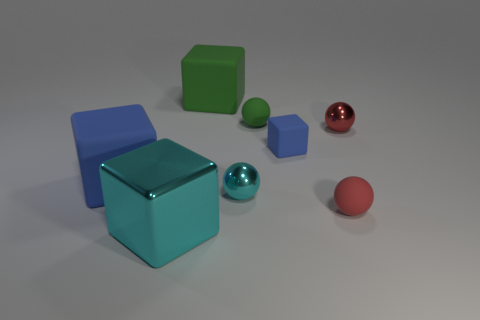What is the small green thing made of?
Ensure brevity in your answer.  Rubber. How many other rubber objects have the same shape as the tiny green matte thing?
Provide a short and direct response. 1. There is a big cube that is the same color as the tiny rubber block; what is its material?
Offer a terse response. Rubber. There is a matte cube to the left of the cyan object in front of the rubber sphere that is in front of the large blue cube; what color is it?
Provide a succinct answer. Blue. What number of big things are either green objects or red metal objects?
Ensure brevity in your answer.  1. Is the number of red metal spheres that are left of the big metal cube the same as the number of blue things?
Your response must be concise. No. Are there any small red matte balls behind the small block?
Provide a succinct answer. No. What number of matte objects are either tiny gray cylinders or large blue things?
Provide a short and direct response. 1. How many shiny balls are behind the small blue cube?
Keep it short and to the point. 1. Are there any red shiny things that have the same size as the red rubber ball?
Offer a terse response. Yes. 